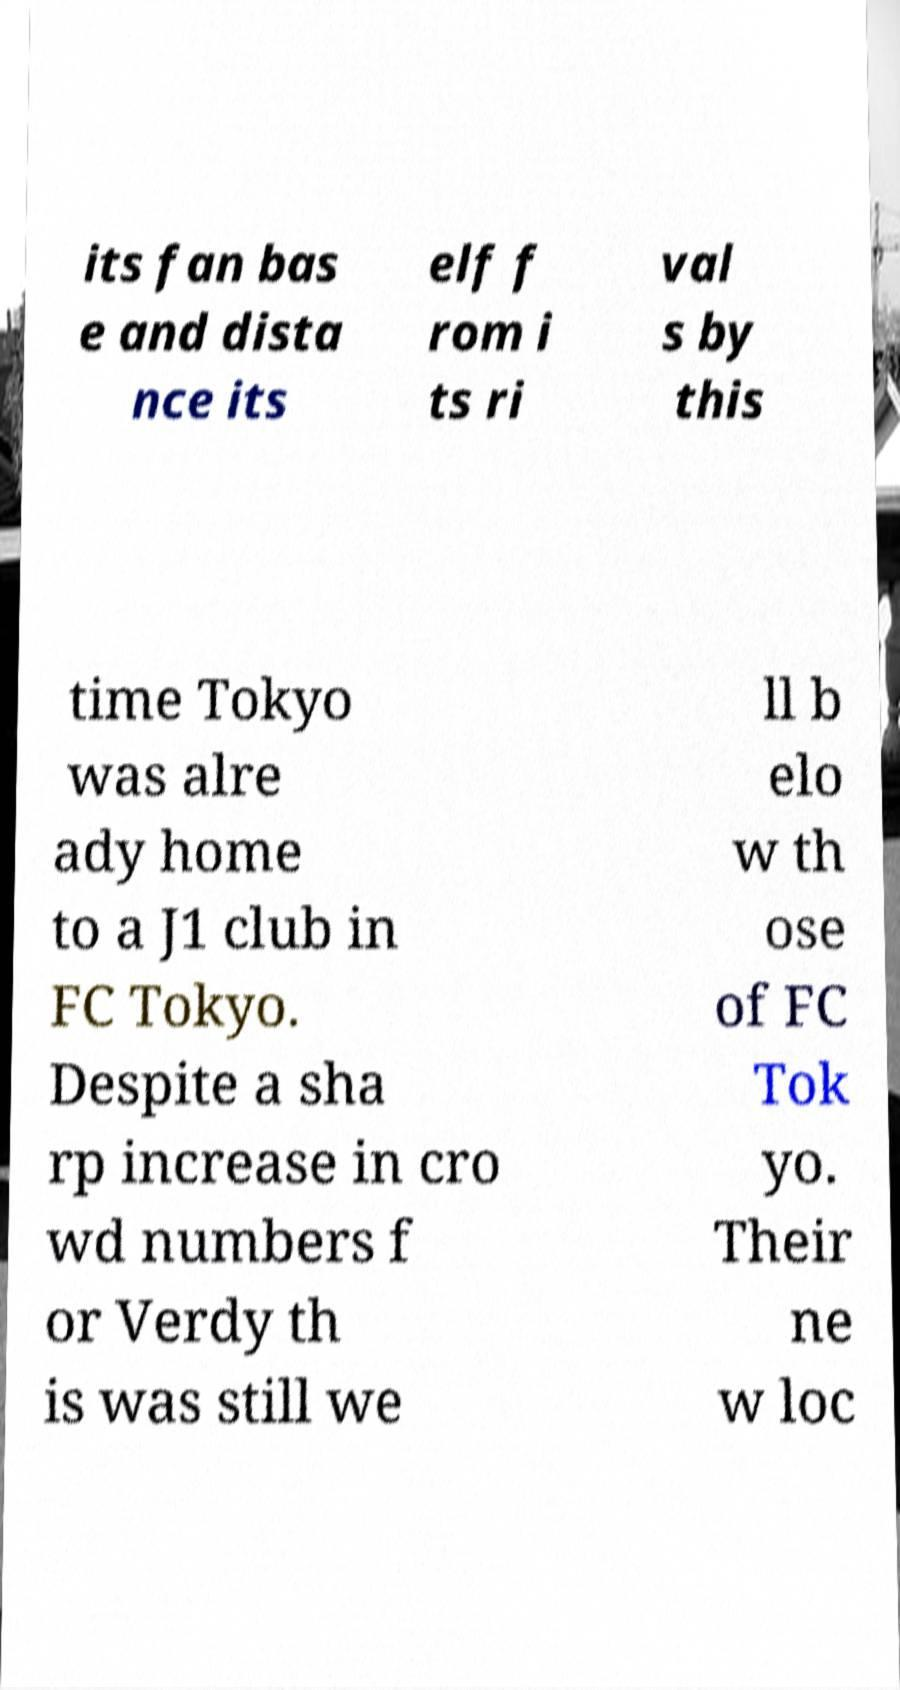Can you read and provide the text displayed in the image?This photo seems to have some interesting text. Can you extract and type it out for me? its fan bas e and dista nce its elf f rom i ts ri val s by this time Tokyo was alre ady home to a J1 club in FC Tokyo. Despite a sha rp increase in cro wd numbers f or Verdy th is was still we ll b elo w th ose of FC Tok yo. Their ne w loc 